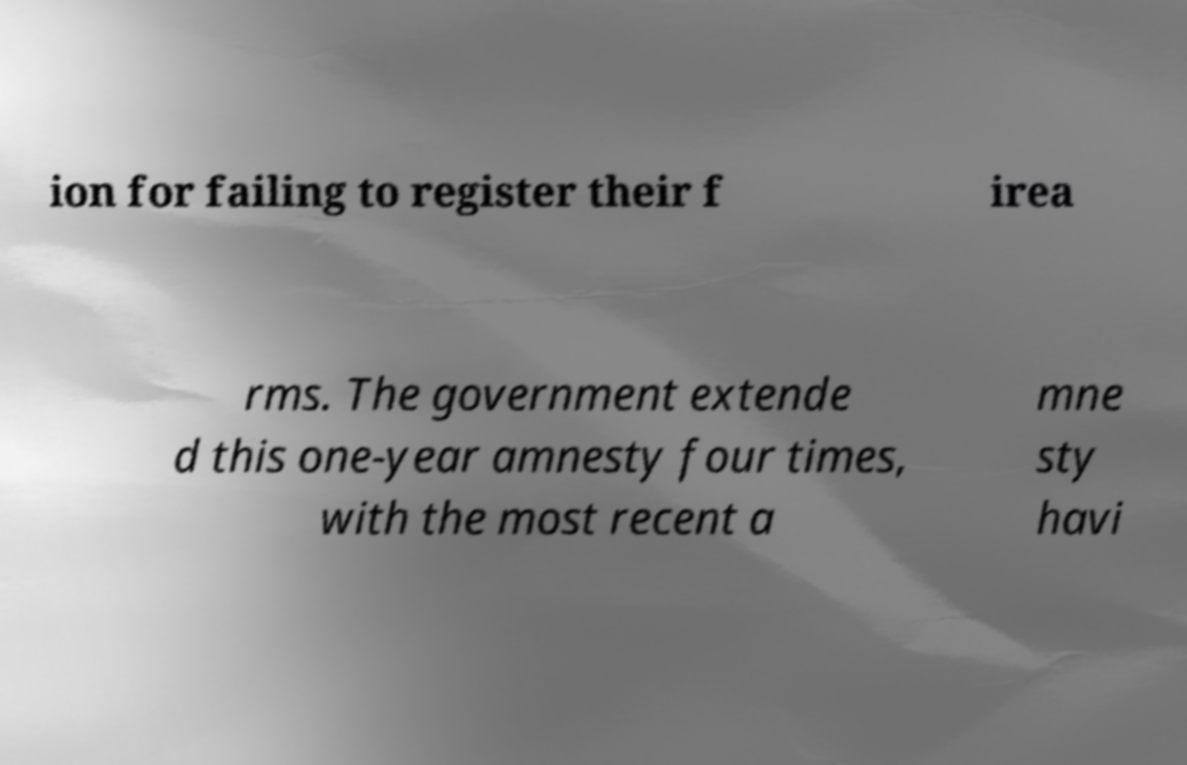Could you assist in decoding the text presented in this image and type it out clearly? ion for failing to register their f irea rms. The government extende d this one-year amnesty four times, with the most recent a mne sty havi 